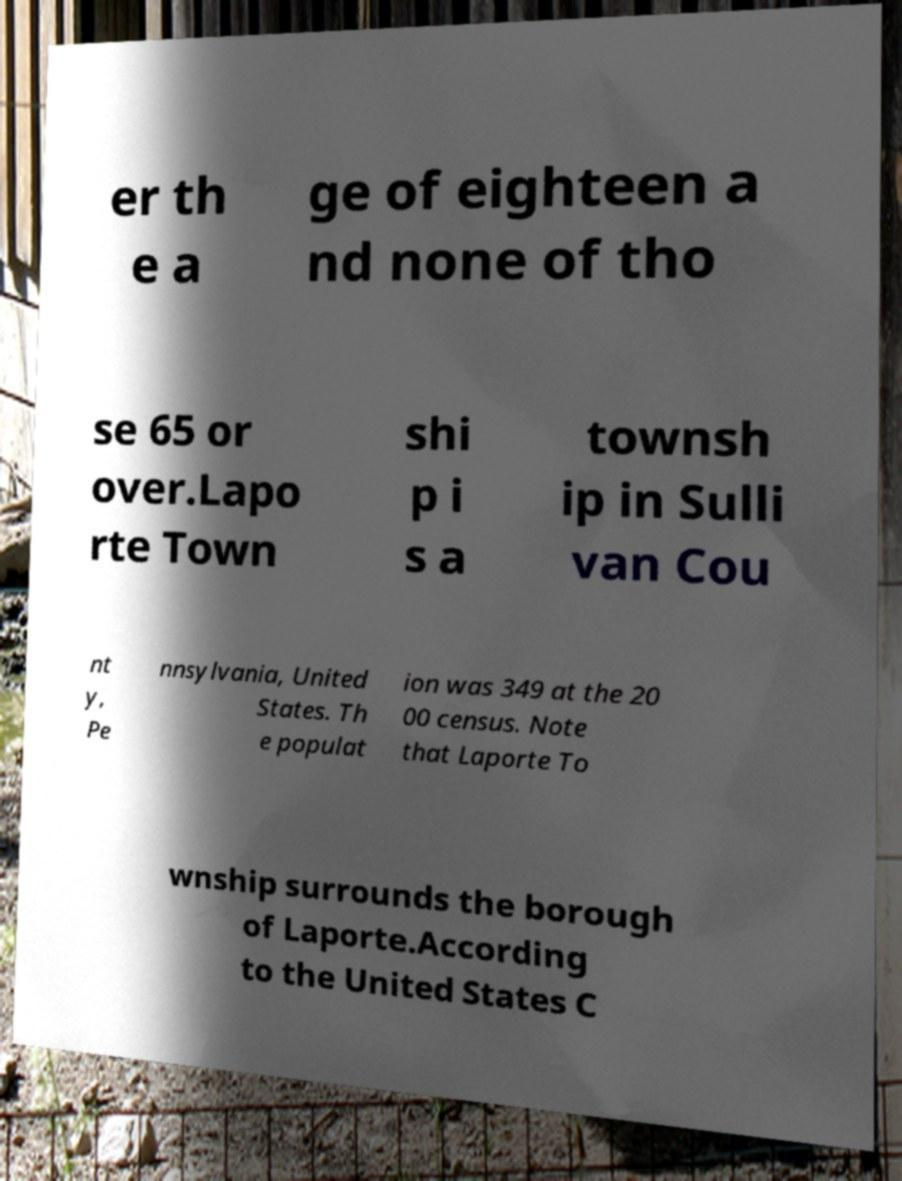Can you read and provide the text displayed in the image?This photo seems to have some interesting text. Can you extract and type it out for me? er th e a ge of eighteen a nd none of tho se 65 or over.Lapo rte Town shi p i s a townsh ip in Sulli van Cou nt y, Pe nnsylvania, United States. Th e populat ion was 349 at the 20 00 census. Note that Laporte To wnship surrounds the borough of Laporte.According to the United States C 